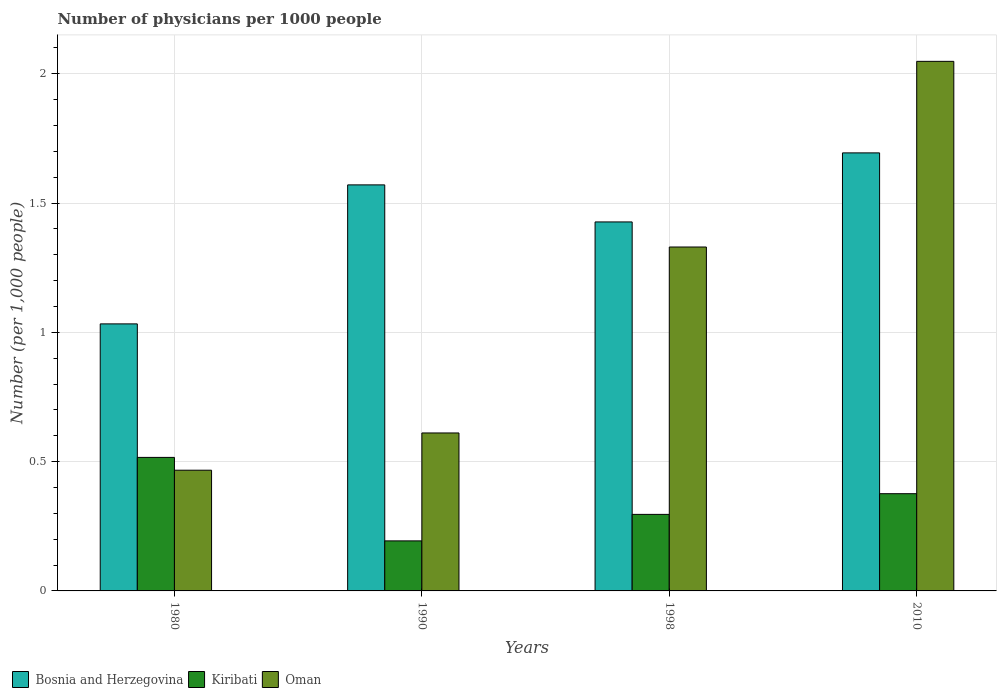How many different coloured bars are there?
Your answer should be compact. 3. Are the number of bars on each tick of the X-axis equal?
Offer a very short reply. Yes. In how many cases, is the number of bars for a given year not equal to the number of legend labels?
Ensure brevity in your answer.  0. What is the number of physicians in Oman in 1990?
Offer a very short reply. 0.61. Across all years, what is the maximum number of physicians in Bosnia and Herzegovina?
Your answer should be very brief. 1.69. Across all years, what is the minimum number of physicians in Kiribati?
Your answer should be compact. 0.19. In which year was the number of physicians in Bosnia and Herzegovina maximum?
Provide a succinct answer. 2010. What is the total number of physicians in Bosnia and Herzegovina in the graph?
Make the answer very short. 5.72. What is the difference between the number of physicians in Kiribati in 1998 and that in 2010?
Your answer should be very brief. -0.08. What is the difference between the number of physicians in Kiribati in 1998 and the number of physicians in Oman in 1990?
Keep it short and to the point. -0.31. What is the average number of physicians in Oman per year?
Provide a short and direct response. 1.11. In the year 1980, what is the difference between the number of physicians in Bosnia and Herzegovina and number of physicians in Oman?
Provide a succinct answer. 0.57. In how many years, is the number of physicians in Kiribati greater than 1.7?
Ensure brevity in your answer.  0. What is the ratio of the number of physicians in Kiribati in 1980 to that in 1990?
Your answer should be very brief. 2.67. Is the number of physicians in Bosnia and Herzegovina in 1990 less than that in 2010?
Give a very brief answer. Yes. What is the difference between the highest and the second highest number of physicians in Bosnia and Herzegovina?
Offer a very short reply. 0.12. What is the difference between the highest and the lowest number of physicians in Kiribati?
Make the answer very short. 0.32. What does the 3rd bar from the left in 1998 represents?
Your answer should be compact. Oman. What does the 3rd bar from the right in 1990 represents?
Make the answer very short. Bosnia and Herzegovina. How many years are there in the graph?
Your answer should be very brief. 4. What is the difference between two consecutive major ticks on the Y-axis?
Offer a very short reply. 0.5. Are the values on the major ticks of Y-axis written in scientific E-notation?
Offer a very short reply. No. Does the graph contain grids?
Provide a short and direct response. Yes. Where does the legend appear in the graph?
Provide a succinct answer. Bottom left. How many legend labels are there?
Provide a succinct answer. 3. How are the legend labels stacked?
Your response must be concise. Horizontal. What is the title of the graph?
Offer a very short reply. Number of physicians per 1000 people. What is the label or title of the Y-axis?
Give a very brief answer. Number (per 1,0 people). What is the Number (per 1,000 people) in Bosnia and Herzegovina in 1980?
Your response must be concise. 1.03. What is the Number (per 1,000 people) in Kiribati in 1980?
Your response must be concise. 0.52. What is the Number (per 1,000 people) of Oman in 1980?
Make the answer very short. 0.47. What is the Number (per 1,000 people) of Bosnia and Herzegovina in 1990?
Give a very brief answer. 1.57. What is the Number (per 1,000 people) of Kiribati in 1990?
Provide a succinct answer. 0.19. What is the Number (per 1,000 people) in Oman in 1990?
Make the answer very short. 0.61. What is the Number (per 1,000 people) of Bosnia and Herzegovina in 1998?
Your answer should be very brief. 1.43. What is the Number (per 1,000 people) in Kiribati in 1998?
Ensure brevity in your answer.  0.3. What is the Number (per 1,000 people) of Oman in 1998?
Offer a very short reply. 1.33. What is the Number (per 1,000 people) in Bosnia and Herzegovina in 2010?
Provide a short and direct response. 1.69. What is the Number (per 1,000 people) of Kiribati in 2010?
Keep it short and to the point. 0.38. What is the Number (per 1,000 people) in Oman in 2010?
Your answer should be compact. 2.05. Across all years, what is the maximum Number (per 1,000 people) in Bosnia and Herzegovina?
Your response must be concise. 1.69. Across all years, what is the maximum Number (per 1,000 people) of Kiribati?
Your answer should be very brief. 0.52. Across all years, what is the maximum Number (per 1,000 people) in Oman?
Keep it short and to the point. 2.05. Across all years, what is the minimum Number (per 1,000 people) of Bosnia and Herzegovina?
Your response must be concise. 1.03. Across all years, what is the minimum Number (per 1,000 people) of Kiribati?
Provide a short and direct response. 0.19. Across all years, what is the minimum Number (per 1,000 people) of Oman?
Your answer should be very brief. 0.47. What is the total Number (per 1,000 people) in Bosnia and Herzegovina in the graph?
Ensure brevity in your answer.  5.72. What is the total Number (per 1,000 people) in Kiribati in the graph?
Offer a terse response. 1.38. What is the total Number (per 1,000 people) in Oman in the graph?
Provide a short and direct response. 4.46. What is the difference between the Number (per 1,000 people) in Bosnia and Herzegovina in 1980 and that in 1990?
Your answer should be very brief. -0.54. What is the difference between the Number (per 1,000 people) in Kiribati in 1980 and that in 1990?
Offer a terse response. 0.32. What is the difference between the Number (per 1,000 people) of Oman in 1980 and that in 1990?
Your response must be concise. -0.14. What is the difference between the Number (per 1,000 people) in Bosnia and Herzegovina in 1980 and that in 1998?
Offer a very short reply. -0.39. What is the difference between the Number (per 1,000 people) of Kiribati in 1980 and that in 1998?
Give a very brief answer. 0.22. What is the difference between the Number (per 1,000 people) in Oman in 1980 and that in 1998?
Ensure brevity in your answer.  -0.86. What is the difference between the Number (per 1,000 people) in Bosnia and Herzegovina in 1980 and that in 2010?
Make the answer very short. -0.66. What is the difference between the Number (per 1,000 people) in Kiribati in 1980 and that in 2010?
Provide a short and direct response. 0.14. What is the difference between the Number (per 1,000 people) in Oman in 1980 and that in 2010?
Make the answer very short. -1.58. What is the difference between the Number (per 1,000 people) in Bosnia and Herzegovina in 1990 and that in 1998?
Ensure brevity in your answer.  0.14. What is the difference between the Number (per 1,000 people) in Kiribati in 1990 and that in 1998?
Provide a short and direct response. -0.1. What is the difference between the Number (per 1,000 people) of Oman in 1990 and that in 1998?
Your answer should be very brief. -0.72. What is the difference between the Number (per 1,000 people) in Bosnia and Herzegovina in 1990 and that in 2010?
Offer a very short reply. -0.12. What is the difference between the Number (per 1,000 people) of Kiribati in 1990 and that in 2010?
Make the answer very short. -0.18. What is the difference between the Number (per 1,000 people) in Oman in 1990 and that in 2010?
Your answer should be very brief. -1.44. What is the difference between the Number (per 1,000 people) in Bosnia and Herzegovina in 1998 and that in 2010?
Your response must be concise. -0.27. What is the difference between the Number (per 1,000 people) of Kiribati in 1998 and that in 2010?
Give a very brief answer. -0.08. What is the difference between the Number (per 1,000 people) of Oman in 1998 and that in 2010?
Keep it short and to the point. -0.72. What is the difference between the Number (per 1,000 people) of Bosnia and Herzegovina in 1980 and the Number (per 1,000 people) of Kiribati in 1990?
Give a very brief answer. 0.84. What is the difference between the Number (per 1,000 people) in Bosnia and Herzegovina in 1980 and the Number (per 1,000 people) in Oman in 1990?
Provide a succinct answer. 0.42. What is the difference between the Number (per 1,000 people) of Kiribati in 1980 and the Number (per 1,000 people) of Oman in 1990?
Your answer should be compact. -0.09. What is the difference between the Number (per 1,000 people) in Bosnia and Herzegovina in 1980 and the Number (per 1,000 people) in Kiribati in 1998?
Offer a terse response. 0.74. What is the difference between the Number (per 1,000 people) of Bosnia and Herzegovina in 1980 and the Number (per 1,000 people) of Oman in 1998?
Provide a succinct answer. -0.3. What is the difference between the Number (per 1,000 people) in Kiribati in 1980 and the Number (per 1,000 people) in Oman in 1998?
Offer a terse response. -0.81. What is the difference between the Number (per 1,000 people) of Bosnia and Herzegovina in 1980 and the Number (per 1,000 people) of Kiribati in 2010?
Keep it short and to the point. 0.66. What is the difference between the Number (per 1,000 people) in Bosnia and Herzegovina in 1980 and the Number (per 1,000 people) in Oman in 2010?
Make the answer very short. -1.02. What is the difference between the Number (per 1,000 people) of Kiribati in 1980 and the Number (per 1,000 people) of Oman in 2010?
Provide a short and direct response. -1.53. What is the difference between the Number (per 1,000 people) in Bosnia and Herzegovina in 1990 and the Number (per 1,000 people) in Kiribati in 1998?
Make the answer very short. 1.27. What is the difference between the Number (per 1,000 people) of Bosnia and Herzegovina in 1990 and the Number (per 1,000 people) of Oman in 1998?
Your response must be concise. 0.24. What is the difference between the Number (per 1,000 people) of Kiribati in 1990 and the Number (per 1,000 people) of Oman in 1998?
Give a very brief answer. -1.14. What is the difference between the Number (per 1,000 people) of Bosnia and Herzegovina in 1990 and the Number (per 1,000 people) of Kiribati in 2010?
Provide a succinct answer. 1.19. What is the difference between the Number (per 1,000 people) in Bosnia and Herzegovina in 1990 and the Number (per 1,000 people) in Oman in 2010?
Keep it short and to the point. -0.48. What is the difference between the Number (per 1,000 people) of Kiribati in 1990 and the Number (per 1,000 people) of Oman in 2010?
Keep it short and to the point. -1.85. What is the difference between the Number (per 1,000 people) of Bosnia and Herzegovina in 1998 and the Number (per 1,000 people) of Kiribati in 2010?
Make the answer very short. 1.05. What is the difference between the Number (per 1,000 people) in Bosnia and Herzegovina in 1998 and the Number (per 1,000 people) in Oman in 2010?
Offer a terse response. -0.62. What is the difference between the Number (per 1,000 people) of Kiribati in 1998 and the Number (per 1,000 people) of Oman in 2010?
Make the answer very short. -1.75. What is the average Number (per 1,000 people) of Bosnia and Herzegovina per year?
Provide a succinct answer. 1.43. What is the average Number (per 1,000 people) of Kiribati per year?
Your answer should be compact. 0.35. What is the average Number (per 1,000 people) of Oman per year?
Your answer should be very brief. 1.11. In the year 1980, what is the difference between the Number (per 1,000 people) of Bosnia and Herzegovina and Number (per 1,000 people) of Kiribati?
Make the answer very short. 0.52. In the year 1980, what is the difference between the Number (per 1,000 people) of Bosnia and Herzegovina and Number (per 1,000 people) of Oman?
Your response must be concise. 0.57. In the year 1980, what is the difference between the Number (per 1,000 people) of Kiribati and Number (per 1,000 people) of Oman?
Your answer should be compact. 0.05. In the year 1990, what is the difference between the Number (per 1,000 people) of Bosnia and Herzegovina and Number (per 1,000 people) of Kiribati?
Your answer should be very brief. 1.38. In the year 1990, what is the difference between the Number (per 1,000 people) in Bosnia and Herzegovina and Number (per 1,000 people) in Oman?
Keep it short and to the point. 0.96. In the year 1990, what is the difference between the Number (per 1,000 people) in Kiribati and Number (per 1,000 people) in Oman?
Your answer should be very brief. -0.42. In the year 1998, what is the difference between the Number (per 1,000 people) of Bosnia and Herzegovina and Number (per 1,000 people) of Kiribati?
Provide a succinct answer. 1.13. In the year 1998, what is the difference between the Number (per 1,000 people) of Bosnia and Herzegovina and Number (per 1,000 people) of Oman?
Make the answer very short. 0.1. In the year 1998, what is the difference between the Number (per 1,000 people) of Kiribati and Number (per 1,000 people) of Oman?
Provide a short and direct response. -1.03. In the year 2010, what is the difference between the Number (per 1,000 people) in Bosnia and Herzegovina and Number (per 1,000 people) in Kiribati?
Keep it short and to the point. 1.32. In the year 2010, what is the difference between the Number (per 1,000 people) of Bosnia and Herzegovina and Number (per 1,000 people) of Oman?
Keep it short and to the point. -0.35. In the year 2010, what is the difference between the Number (per 1,000 people) in Kiribati and Number (per 1,000 people) in Oman?
Provide a succinct answer. -1.67. What is the ratio of the Number (per 1,000 people) in Bosnia and Herzegovina in 1980 to that in 1990?
Your answer should be very brief. 0.66. What is the ratio of the Number (per 1,000 people) of Kiribati in 1980 to that in 1990?
Provide a succinct answer. 2.67. What is the ratio of the Number (per 1,000 people) in Oman in 1980 to that in 1990?
Your answer should be compact. 0.76. What is the ratio of the Number (per 1,000 people) of Bosnia and Herzegovina in 1980 to that in 1998?
Your answer should be very brief. 0.72. What is the ratio of the Number (per 1,000 people) of Kiribati in 1980 to that in 1998?
Your response must be concise. 1.74. What is the ratio of the Number (per 1,000 people) of Oman in 1980 to that in 1998?
Your response must be concise. 0.35. What is the ratio of the Number (per 1,000 people) of Bosnia and Herzegovina in 1980 to that in 2010?
Offer a very short reply. 0.61. What is the ratio of the Number (per 1,000 people) of Kiribati in 1980 to that in 2010?
Your answer should be compact. 1.37. What is the ratio of the Number (per 1,000 people) of Oman in 1980 to that in 2010?
Your response must be concise. 0.23. What is the ratio of the Number (per 1,000 people) in Bosnia and Herzegovina in 1990 to that in 1998?
Offer a very short reply. 1.1. What is the ratio of the Number (per 1,000 people) in Kiribati in 1990 to that in 1998?
Your response must be concise. 0.65. What is the ratio of the Number (per 1,000 people) in Oman in 1990 to that in 1998?
Make the answer very short. 0.46. What is the ratio of the Number (per 1,000 people) in Bosnia and Herzegovina in 1990 to that in 2010?
Provide a succinct answer. 0.93. What is the ratio of the Number (per 1,000 people) of Kiribati in 1990 to that in 2010?
Provide a short and direct response. 0.51. What is the ratio of the Number (per 1,000 people) of Oman in 1990 to that in 2010?
Make the answer very short. 0.3. What is the ratio of the Number (per 1,000 people) in Bosnia and Herzegovina in 1998 to that in 2010?
Keep it short and to the point. 0.84. What is the ratio of the Number (per 1,000 people) in Kiribati in 1998 to that in 2010?
Provide a succinct answer. 0.79. What is the ratio of the Number (per 1,000 people) of Oman in 1998 to that in 2010?
Give a very brief answer. 0.65. What is the difference between the highest and the second highest Number (per 1,000 people) of Bosnia and Herzegovina?
Ensure brevity in your answer.  0.12. What is the difference between the highest and the second highest Number (per 1,000 people) of Kiribati?
Make the answer very short. 0.14. What is the difference between the highest and the second highest Number (per 1,000 people) of Oman?
Keep it short and to the point. 0.72. What is the difference between the highest and the lowest Number (per 1,000 people) of Bosnia and Herzegovina?
Provide a succinct answer. 0.66. What is the difference between the highest and the lowest Number (per 1,000 people) in Kiribati?
Give a very brief answer. 0.32. What is the difference between the highest and the lowest Number (per 1,000 people) in Oman?
Your answer should be very brief. 1.58. 